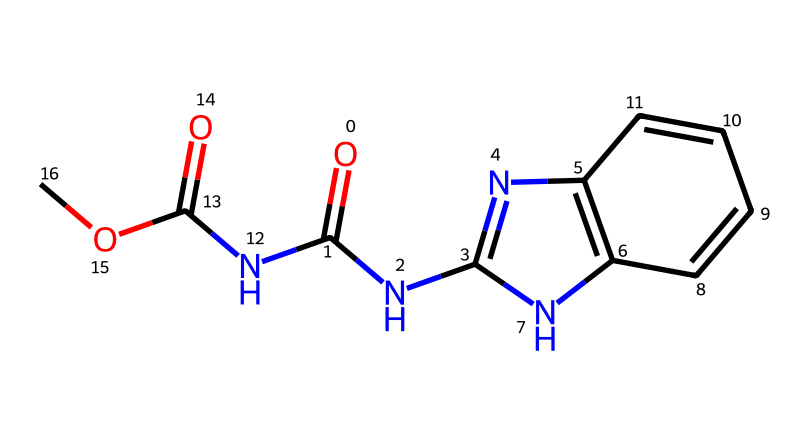What is the name of the chemical represented by the SMILES notation? The SMILES notation corresponds to the structure of carbendazim, a known fungicide.
Answer: carbendazim How many nitrogen atoms are in the chemical structure? By analyzing the structure represented in the SMILES, there are three nitrogen atoms present.
Answer: 3 What functional groups are present in carbendazim? The structure contains amide and ester functional groups, identified by the presence of the -C(=O)N- and -C(=O)O- motifs.
Answer: amide, ester Is carbendazim soluble in water? Due to its polar functional groups, carbendazim is expected to have moderate solubility in water.
Answer: moderate solubility What is the primary use of carbendazim in agriculture? Carbendazim is primarily used as a fungicide to control fungal diseases in crops.
Answer: fungicide In terms of its structure, what type of chemical is carbendazim classified as? Given its properties and structure, carbendazim is classified as a benzimidazole derivative.
Answer: benzimidazole How many carbon atoms are present in the chemical structure? Upon examining the structure, there are six carbon atoms in the carbendazim chemical structure.
Answer: 6 